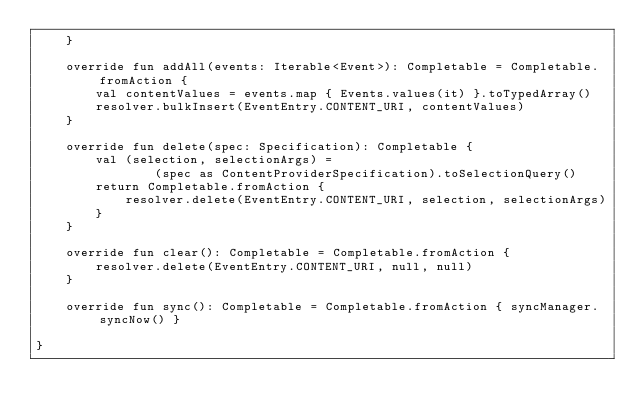<code> <loc_0><loc_0><loc_500><loc_500><_Kotlin_>    }

    override fun addAll(events: Iterable<Event>): Completable = Completable.fromAction {
        val contentValues = events.map { Events.values(it) }.toTypedArray()
        resolver.bulkInsert(EventEntry.CONTENT_URI, contentValues)
    }

    override fun delete(spec: Specification): Completable {
        val (selection, selectionArgs) =
                (spec as ContentProviderSpecification).toSelectionQuery()
        return Completable.fromAction {
            resolver.delete(EventEntry.CONTENT_URI, selection, selectionArgs)
        }
    }

    override fun clear(): Completable = Completable.fromAction {
        resolver.delete(EventEntry.CONTENT_URI, null, null)
    }

    override fun sync(): Completable = Completable.fromAction { syncManager.syncNow() }

}
</code> 